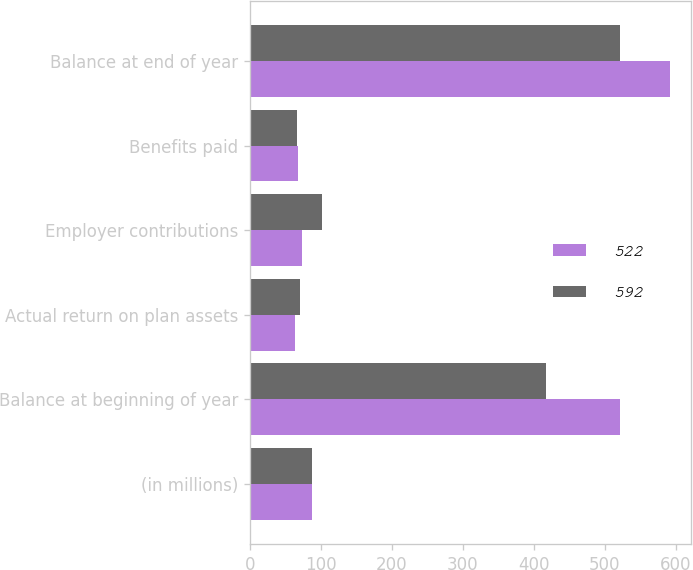<chart> <loc_0><loc_0><loc_500><loc_500><stacked_bar_chart><ecel><fcel>(in millions)<fcel>Balance at beginning of year<fcel>Actual return on plan assets<fcel>Employer contributions<fcel>Benefits paid<fcel>Balance at end of year<nl><fcel>522<fcel>87.5<fcel>522<fcel>64<fcel>74<fcel>68<fcel>592<nl><fcel>592<fcel>87.5<fcel>417<fcel>70<fcel>101<fcel>66<fcel>522<nl></chart> 